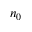<formula> <loc_0><loc_0><loc_500><loc_500>n _ { 0 }</formula> 